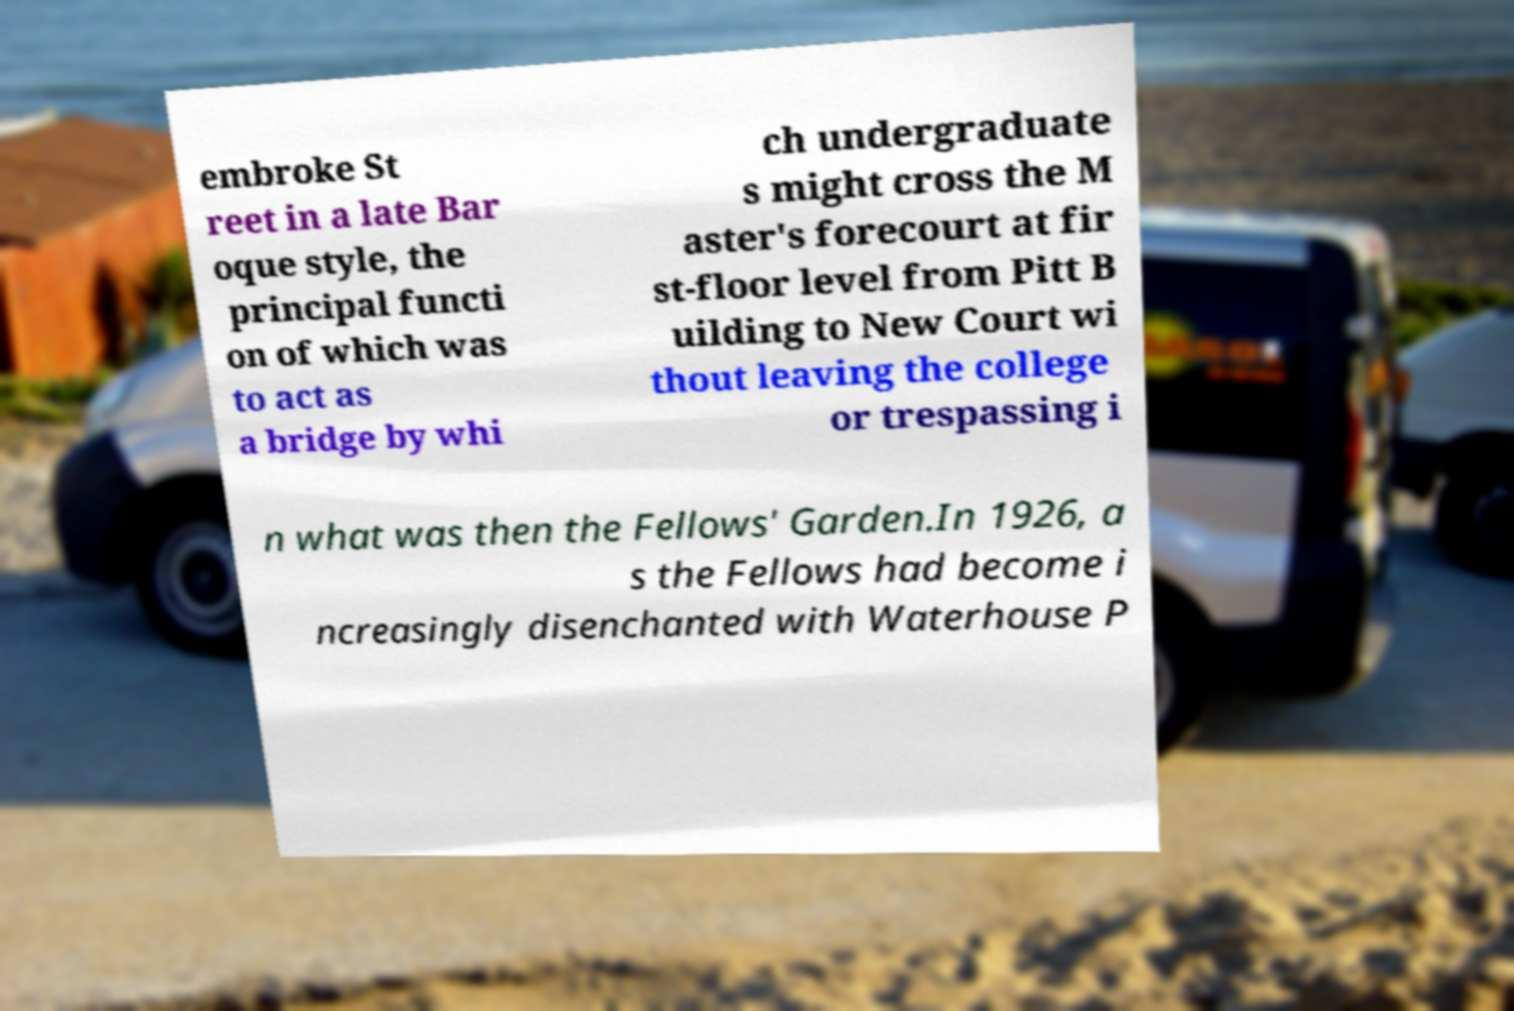Could you extract and type out the text from this image? embroke St reet in a late Bar oque style, the principal functi on of which was to act as a bridge by whi ch undergraduate s might cross the M aster's forecourt at fir st-floor level from Pitt B uilding to New Court wi thout leaving the college or trespassing i n what was then the Fellows' Garden.In 1926, a s the Fellows had become i ncreasingly disenchanted with Waterhouse P 